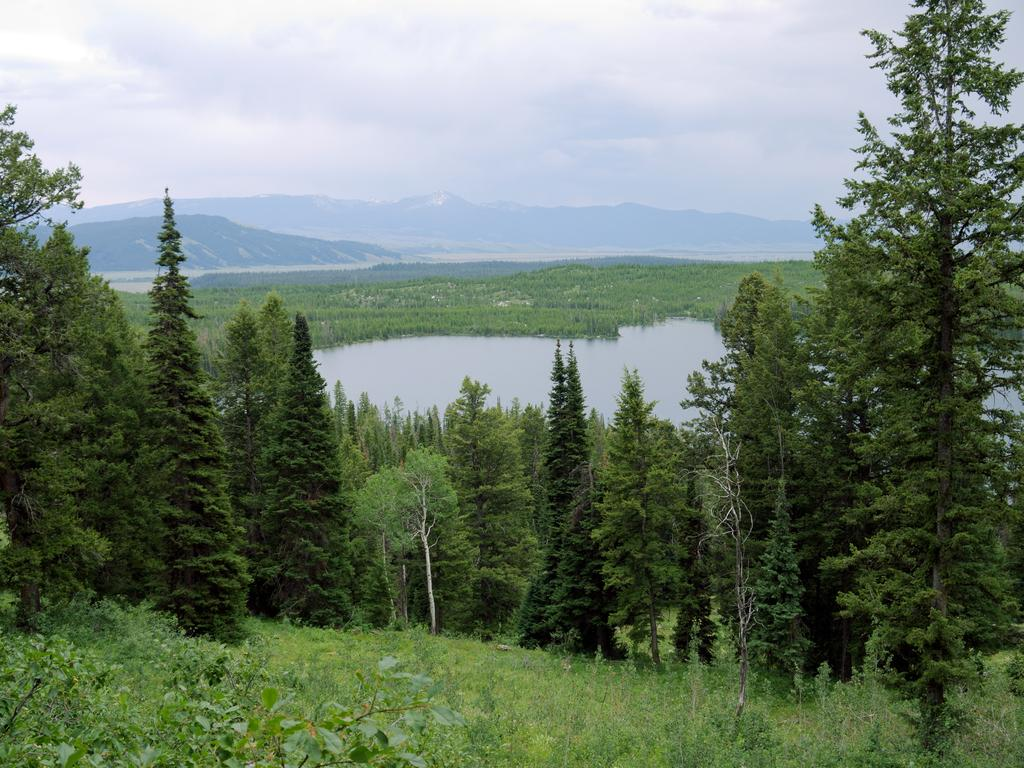What type of natural environment is depicted in the image? The image features many trees, water, and mountains in the background. Can you describe the water in the image? The water is visible in the image, but its specific characteristics are not mentioned. What can be seen in the background of the image? In the background of the image, there are mountains, clouds, and the sky. What direction are the trees growing in the image? The direction in which the trees are growing is not mentioned in the image, and therefore it cannot be determined. Is there a cord visible in the image? There is no mention of a cord in the image, so it is not present. 